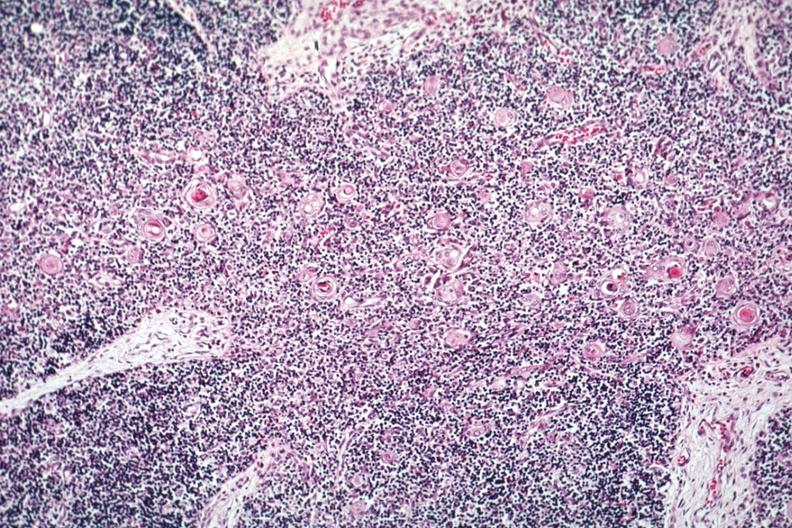s glioma present?
Answer the question using a single word or phrase. No 